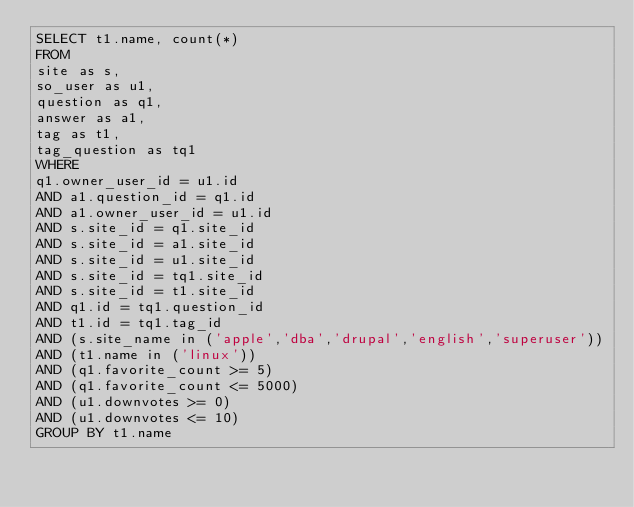<code> <loc_0><loc_0><loc_500><loc_500><_SQL_>SELECT t1.name, count(*)
FROM
site as s,
so_user as u1,
question as q1,
answer as a1,
tag as t1,
tag_question as tq1
WHERE
q1.owner_user_id = u1.id
AND a1.question_id = q1.id
AND a1.owner_user_id = u1.id
AND s.site_id = q1.site_id
AND s.site_id = a1.site_id
AND s.site_id = u1.site_id
AND s.site_id = tq1.site_id
AND s.site_id = t1.site_id
AND q1.id = tq1.question_id
AND t1.id = tq1.tag_id
AND (s.site_name in ('apple','dba','drupal','english','superuser'))
AND (t1.name in ('linux'))
AND (q1.favorite_count >= 5)
AND (q1.favorite_count <= 5000)
AND (u1.downvotes >= 0)
AND (u1.downvotes <= 10)
GROUP BY t1.name</code> 